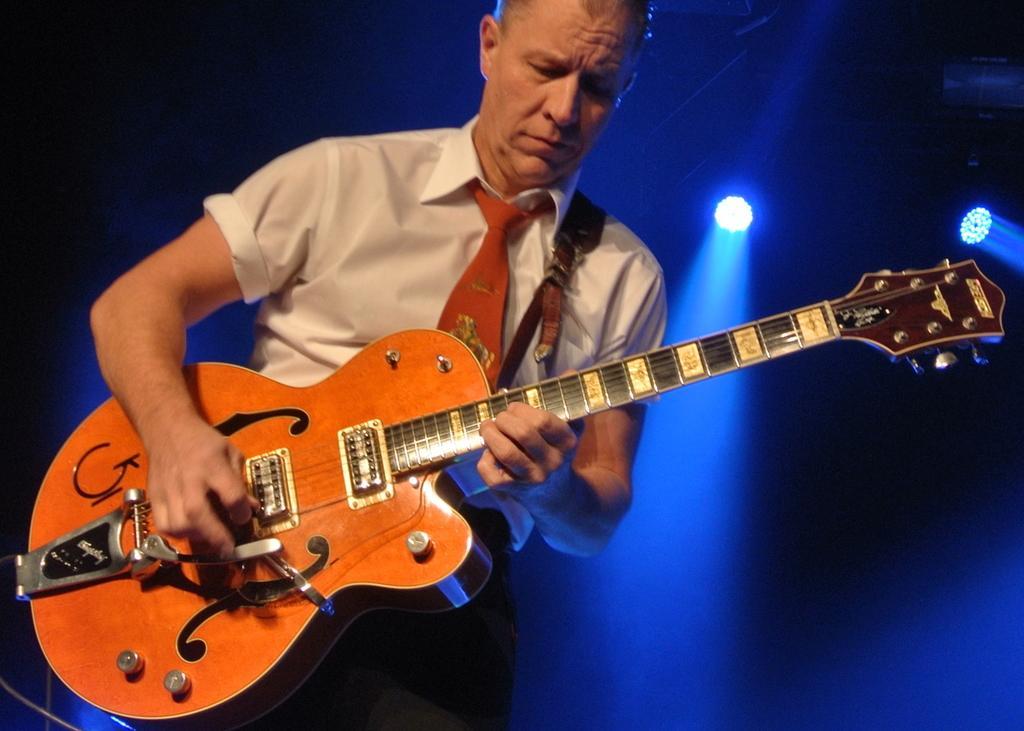In one or two sentences, can you explain what this image depicts? In this image there is a man standing and playing a guitar. He is wearing a white shirt. In the background there are lights. 